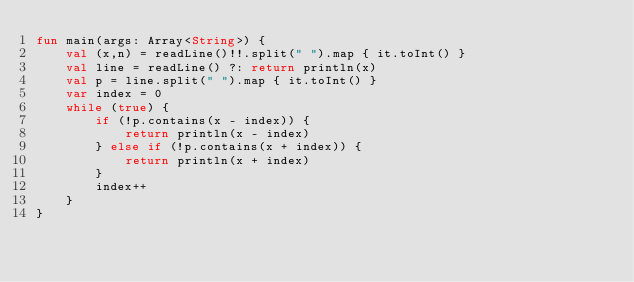Convert code to text. <code><loc_0><loc_0><loc_500><loc_500><_Kotlin_>fun main(args: Array<String>) {
    val (x,n) = readLine()!!.split(" ").map { it.toInt() }
    val line = readLine() ?: return println(x)
    val p = line.split(" ").map { it.toInt() }
    var index = 0
    while (true) {
        if (!p.contains(x - index)) {
            return println(x - index)
        } else if (!p.contains(x + index)) {
            return println(x + index)
        }
        index++
    }
}
</code> 